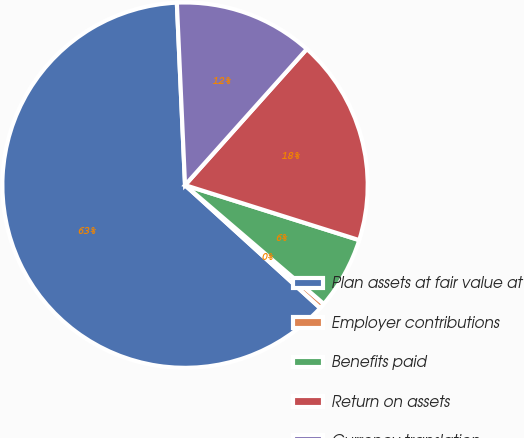Convert chart to OTSL. <chart><loc_0><loc_0><loc_500><loc_500><pie_chart><fcel>Plan assets at fair value at<fcel>Employer contributions<fcel>Benefits paid<fcel>Return on assets<fcel>Currency translation<nl><fcel>62.54%<fcel>0.48%<fcel>6.4%<fcel>18.25%<fcel>12.33%<nl></chart> 